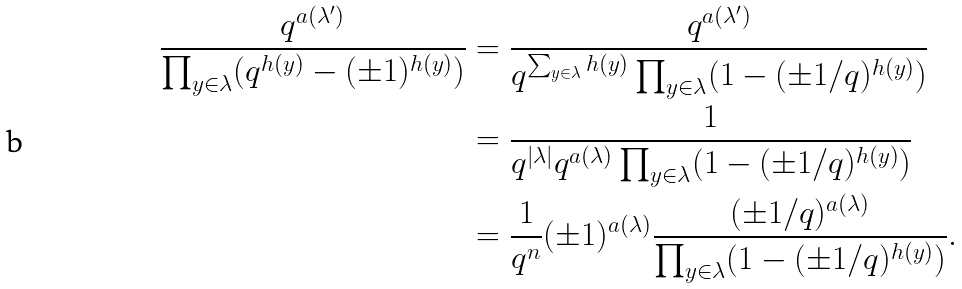<formula> <loc_0><loc_0><loc_500><loc_500>\frac { q ^ { a ( \lambda ^ { \prime } ) } } { \prod _ { y \in \lambda } ( q ^ { h ( y ) } - ( \pm 1 ) ^ { h ( y ) } ) } & = \frac { q ^ { a ( \lambda ^ { \prime } ) } } { q ^ { \sum _ { y \in \lambda } h ( y ) } \prod _ { y \in \lambda } ( 1 - ( \pm 1 / q ) ^ { h ( y ) } ) } \\ & = \frac { 1 } { q ^ { | \lambda | } q ^ { a ( \lambda ) } \prod _ { y \in \lambda } ( 1 - ( \pm 1 / q ) ^ { h ( y ) } ) } \\ & = \frac { 1 } { q ^ { n } } ( \pm 1 ) ^ { a ( \lambda ) } \frac { ( \pm 1 / q ) ^ { a ( \lambda ) } } { \prod _ { y \in \lambda } ( 1 - ( \pm 1 / q ) ^ { h ( y ) } ) } .</formula> 